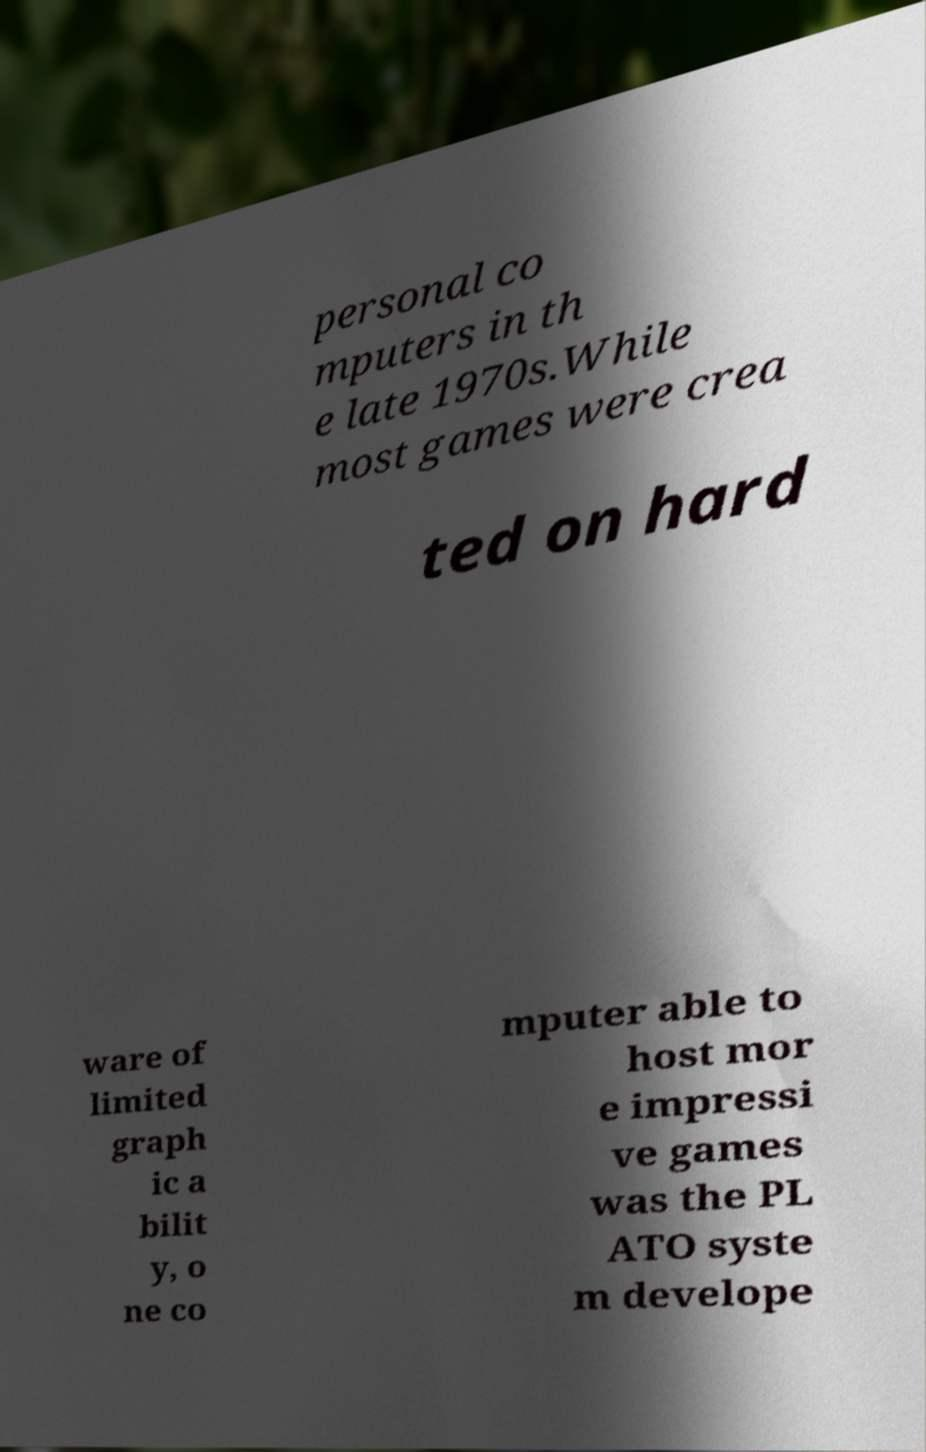I need the written content from this picture converted into text. Can you do that? personal co mputers in th e late 1970s.While most games were crea ted on hard ware of limited graph ic a bilit y, o ne co mputer able to host mor e impressi ve games was the PL ATO syste m develope 